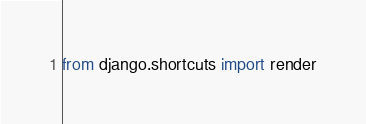<code> <loc_0><loc_0><loc_500><loc_500><_Python_>from django.shortcuts import render

</code> 